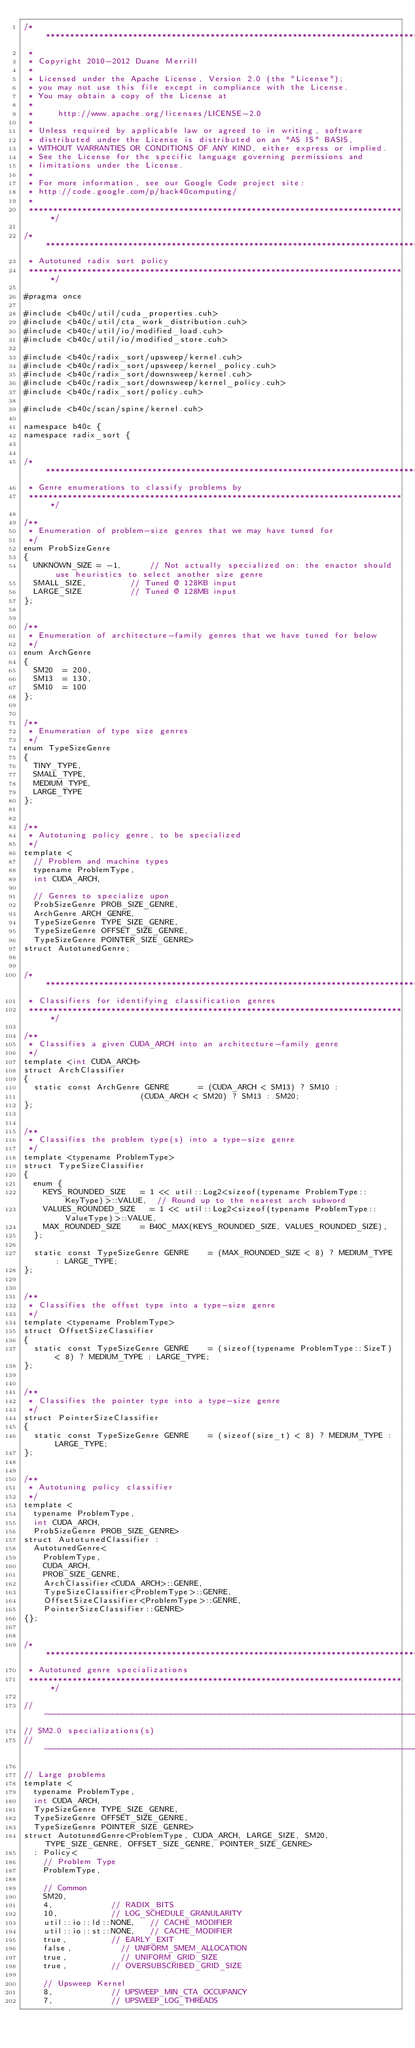<code> <loc_0><loc_0><loc_500><loc_500><_Cuda_>/******************************************************************************
 * 
 * Copyright 2010-2012 Duane Merrill
 * 
 * Licensed under the Apache License, Version 2.0 (the "License");
 * you may not use this file except in compliance with the License.
 * You may obtain a copy of the License at
 * 
 *     http://www.apache.org/licenses/LICENSE-2.0
 *
 * Unless required by applicable law or agreed to in writing, software
 * distributed under the License is distributed on an "AS IS" BASIS,
 * WITHOUT WARRANTIES OR CONDITIONS OF ANY KIND, either express or implied.
 * See the License for the specific language governing permissions and
 * limitations under the License. 
 * 
 * For more information, see our Google Code project site: 
 * http://code.google.com/p/back40computing/
 * 
 ******************************************************************************/

/******************************************************************************
 * Autotuned radix sort policy
 ******************************************************************************/

#pragma once

#include <b40c/util/cuda_properties.cuh>
#include <b40c/util/cta_work_distribution.cuh>
#include <b40c/util/io/modified_load.cuh>
#include <b40c/util/io/modified_store.cuh>

#include <b40c/radix_sort/upsweep/kernel.cuh>
#include <b40c/radix_sort/upsweep/kernel_policy.cuh>
#include <b40c/radix_sort/downsweep/kernel.cuh>
#include <b40c/radix_sort/downsweep/kernel_policy.cuh>
#include <b40c/radix_sort/policy.cuh>

#include <b40c/scan/spine/kernel.cuh>

namespace b40c {
namespace radix_sort {


/******************************************************************************
 * Genre enumerations to classify problems by
 ******************************************************************************/

/**
 * Enumeration of problem-size genres that we may have tuned for
 */
enum ProbSizeGenre
{
	UNKNOWN_SIZE = -1,			// Not actually specialized on: the enactor should use heuristics to select another size genre
	SMALL_SIZE,					// Tuned @ 128KB input
	LARGE_SIZE					// Tuned @ 128MB input
};


/**
 * Enumeration of architecture-family genres that we have tuned for below
 */
enum ArchGenre
{
	SM20 	= 200,
	SM13	= 130,
	SM10	= 100
};


/**
 * Enumeration of type size genres
 */
enum TypeSizeGenre
{
	TINY_TYPE,
	SMALL_TYPE,
	MEDIUM_TYPE,
	LARGE_TYPE
};


/**
 * Autotuning policy genre, to be specialized
 */
template <
	// Problem and machine types
	typename ProblemType,
	int CUDA_ARCH,

	// Genres to specialize upon
	ProbSizeGenre PROB_SIZE_GENRE,
	ArchGenre ARCH_GENRE,
	TypeSizeGenre TYPE_SIZE_GENRE,
	TypeSizeGenre OFFSET_SIZE_GENRE,
	TypeSizeGenre POINTER_SIZE_GENRE>
struct AutotunedGenre;


/******************************************************************************
 * Classifiers for identifying classification genres
 ******************************************************************************/

/**
 * Classifies a given CUDA_ARCH into an architecture-family genre
 */
template <int CUDA_ARCH>
struct ArchClassifier
{
	static const ArchGenre GENRE 			=	(CUDA_ARCH < SM13) ? SM10 :
												(CUDA_ARCH < SM20) ? SM13 : SM20;
};


/**
 * Classifies the problem type(s) into a type-size genre
 */
template <typename ProblemType>
struct TypeSizeClassifier
{
	enum {
		KEYS_ROUNDED_SIZE		= 1 << util::Log2<sizeof(typename ProblemType::KeyType)>::VALUE,	// Round up to the nearest arch subword
		VALUES_ROUNDED_SIZE		= 1 << util::Log2<sizeof(typename ProblemType::ValueType)>::VALUE,
		MAX_ROUNDED_SIZE		= B40C_MAX(KEYS_ROUNDED_SIZE, VALUES_ROUNDED_SIZE),
	};

	static const TypeSizeGenre GENRE 		= (MAX_ROUNDED_SIZE < 8) ? MEDIUM_TYPE : LARGE_TYPE;
};


/**
 * Classifies the offset type into a type-size genre
 */
template <typename ProblemType>
struct OffsetSizeClassifier
{
	static const TypeSizeGenre GENRE 		= (sizeof(typename ProblemType::SizeT) < 8) ? MEDIUM_TYPE : LARGE_TYPE;
};


/**
 * Classifies the pointer type into a type-size genre
 */
struct PointerSizeClassifier
{
	static const TypeSizeGenre GENRE 		= (sizeof(size_t) < 8) ? MEDIUM_TYPE : LARGE_TYPE;
};


/**
 * Autotuning policy classifier
 */
template <
	typename ProblemType,
	int CUDA_ARCH,
	ProbSizeGenre PROB_SIZE_GENRE>
struct AutotunedClassifier :
	AutotunedGenre<
		ProblemType,
		CUDA_ARCH,
		PROB_SIZE_GENRE,
		ArchClassifier<CUDA_ARCH>::GENRE,
		TypeSizeClassifier<ProblemType>::GENRE,
		OffsetSizeClassifier<ProblemType>::GENRE,
		PointerSizeClassifier::GENRE>
{};


/******************************************************************************
 * Autotuned genre specializations
 ******************************************************************************/

//-----------------------------------------------------------------------------
// SM2.0 specializations(s)
//-----------------------------------------------------------------------------

// Large problems
template <
	typename ProblemType,
	int CUDA_ARCH,
	TypeSizeGenre TYPE_SIZE_GENRE,
	TypeSizeGenre OFFSET_SIZE_GENRE,
	TypeSizeGenre POINTER_SIZE_GENRE>
struct AutotunedGenre<ProblemType, CUDA_ARCH, LARGE_SIZE, SM20, TYPE_SIZE_GENRE, OFFSET_SIZE_GENRE, POINTER_SIZE_GENRE>
	: Policy<
		// Problem Type
		ProblemType,

		// Common
		SM20,
		4,						// RADIX_BITS
		10,						// LOG_SCHEDULE_GRANULARITY
		util::io::ld::NONE,		// CACHE_MODIFIER
		util::io::st::NONE,		// CACHE_MODIFIER
		true,					// EARLY_EXIT
		false,					// UNIFORM_SMEM_ALLOCATION
		true, 					// UNIFORM_GRID_SIZE
		true,					// OVERSUBSCRIBED_GRID_SIZE

		// Upsweep Kernel
		8,						// UPSWEEP_MIN_CTA_OCCUPANCY
		7,						// UPSWEEP_LOG_THREADS</code> 